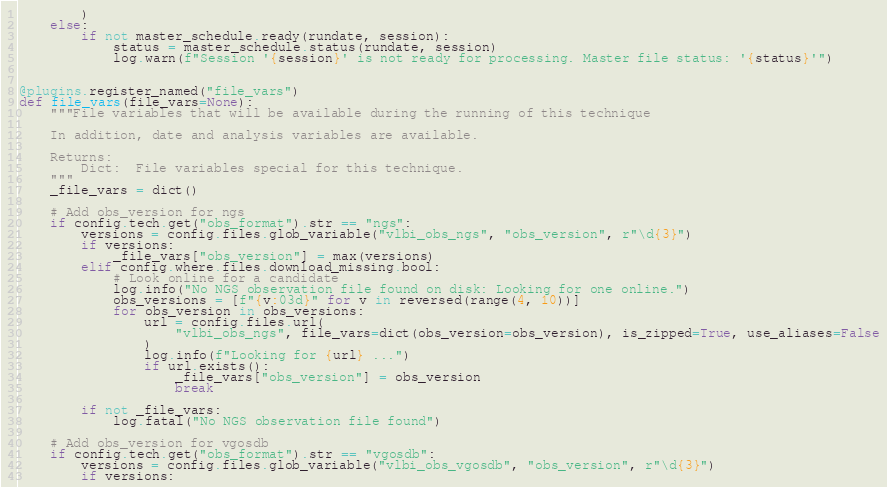Convert code to text. <code><loc_0><loc_0><loc_500><loc_500><_Python_>        )
    else:
        if not master_schedule.ready(rundate, session):
            status = master_schedule.status(rundate, session)
            log.warn(f"Session '{session}' is not ready for processing. Master file status: '{status}'")


@plugins.register_named("file_vars")
def file_vars(file_vars=None):
    """File variables that will be available during the running of this technique

    In addition, date and analysis variables are available.

    Returns:
        Dict:  File variables special for this technique.
    """
    _file_vars = dict()

    # Add obs_version for ngs
    if config.tech.get("obs_format").str == "ngs":
        versions = config.files.glob_variable("vlbi_obs_ngs", "obs_version", r"\d{3}")
        if versions:
            _file_vars["obs_version"] = max(versions)
        elif config.where.files.download_missing.bool:
            # Look online for a candidate
            log.info("No NGS observation file found on disk: Looking for one online.")
            obs_versions = [f"{v:03d}" for v in reversed(range(4, 10))]
            for obs_version in obs_versions:
                url = config.files.url(
                    "vlbi_obs_ngs", file_vars=dict(obs_version=obs_version), is_zipped=True, use_aliases=False
                )
                log.info(f"Looking for {url} ...")
                if url.exists():
                    _file_vars["obs_version"] = obs_version
                    break

        if not _file_vars:
            log.fatal("No NGS observation file found")

    # Add obs_version for vgosdb
    if config.tech.get("obs_format").str == "vgosdb":
        versions = config.files.glob_variable("vlbi_obs_vgosdb", "obs_version", r"\d{3}")
        if versions:</code> 